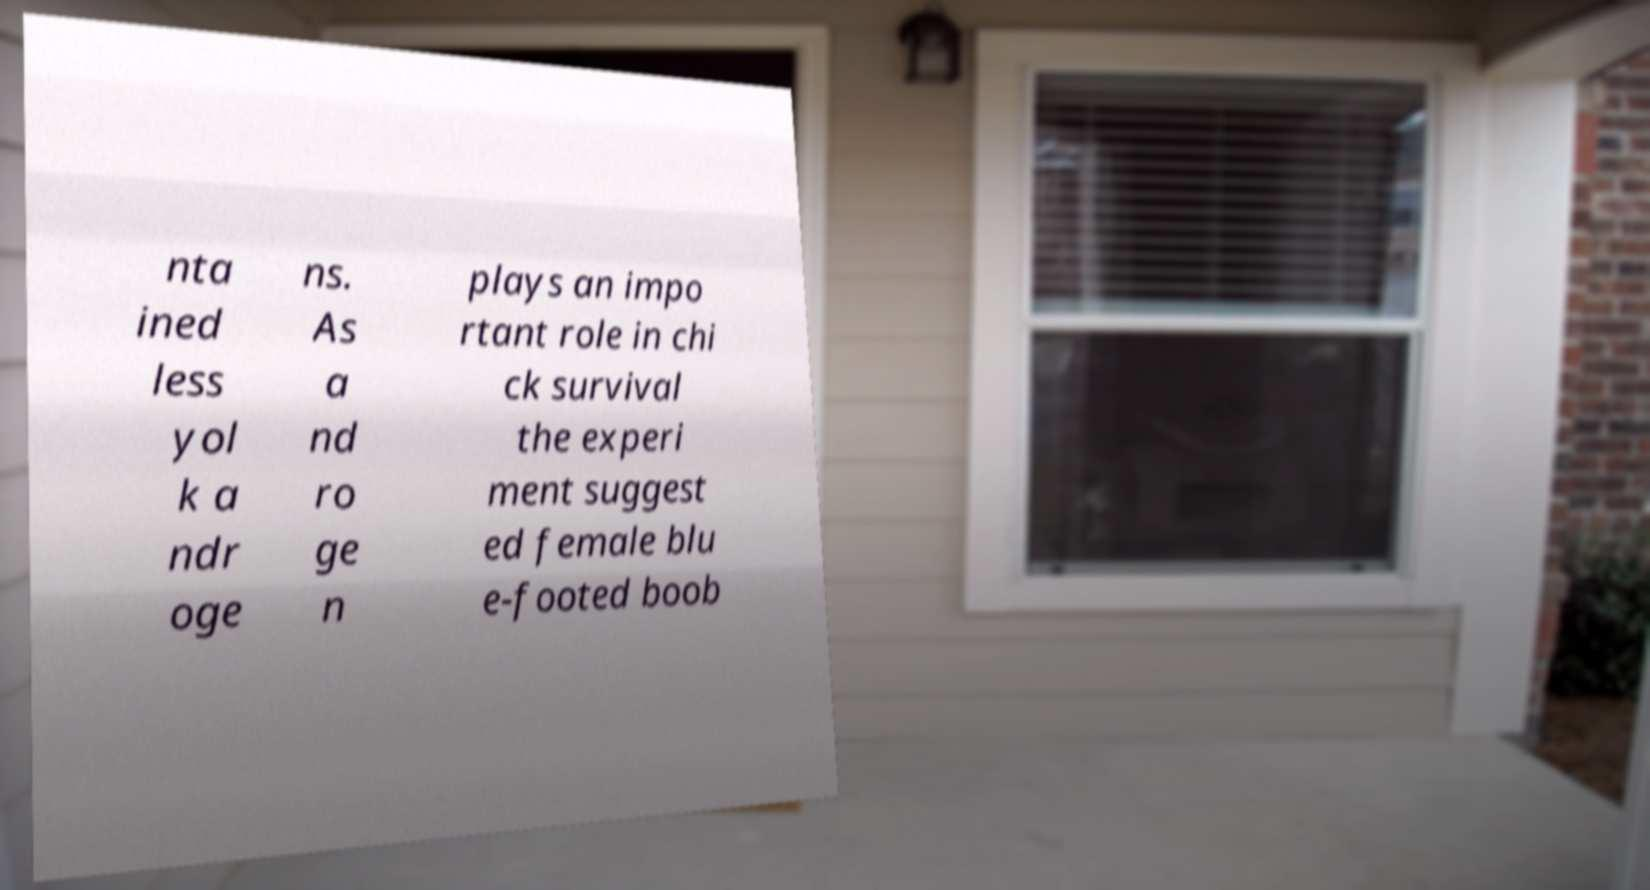What messages or text are displayed in this image? I need them in a readable, typed format. nta ined less yol k a ndr oge ns. As a nd ro ge n plays an impo rtant role in chi ck survival the experi ment suggest ed female blu e-footed boob 